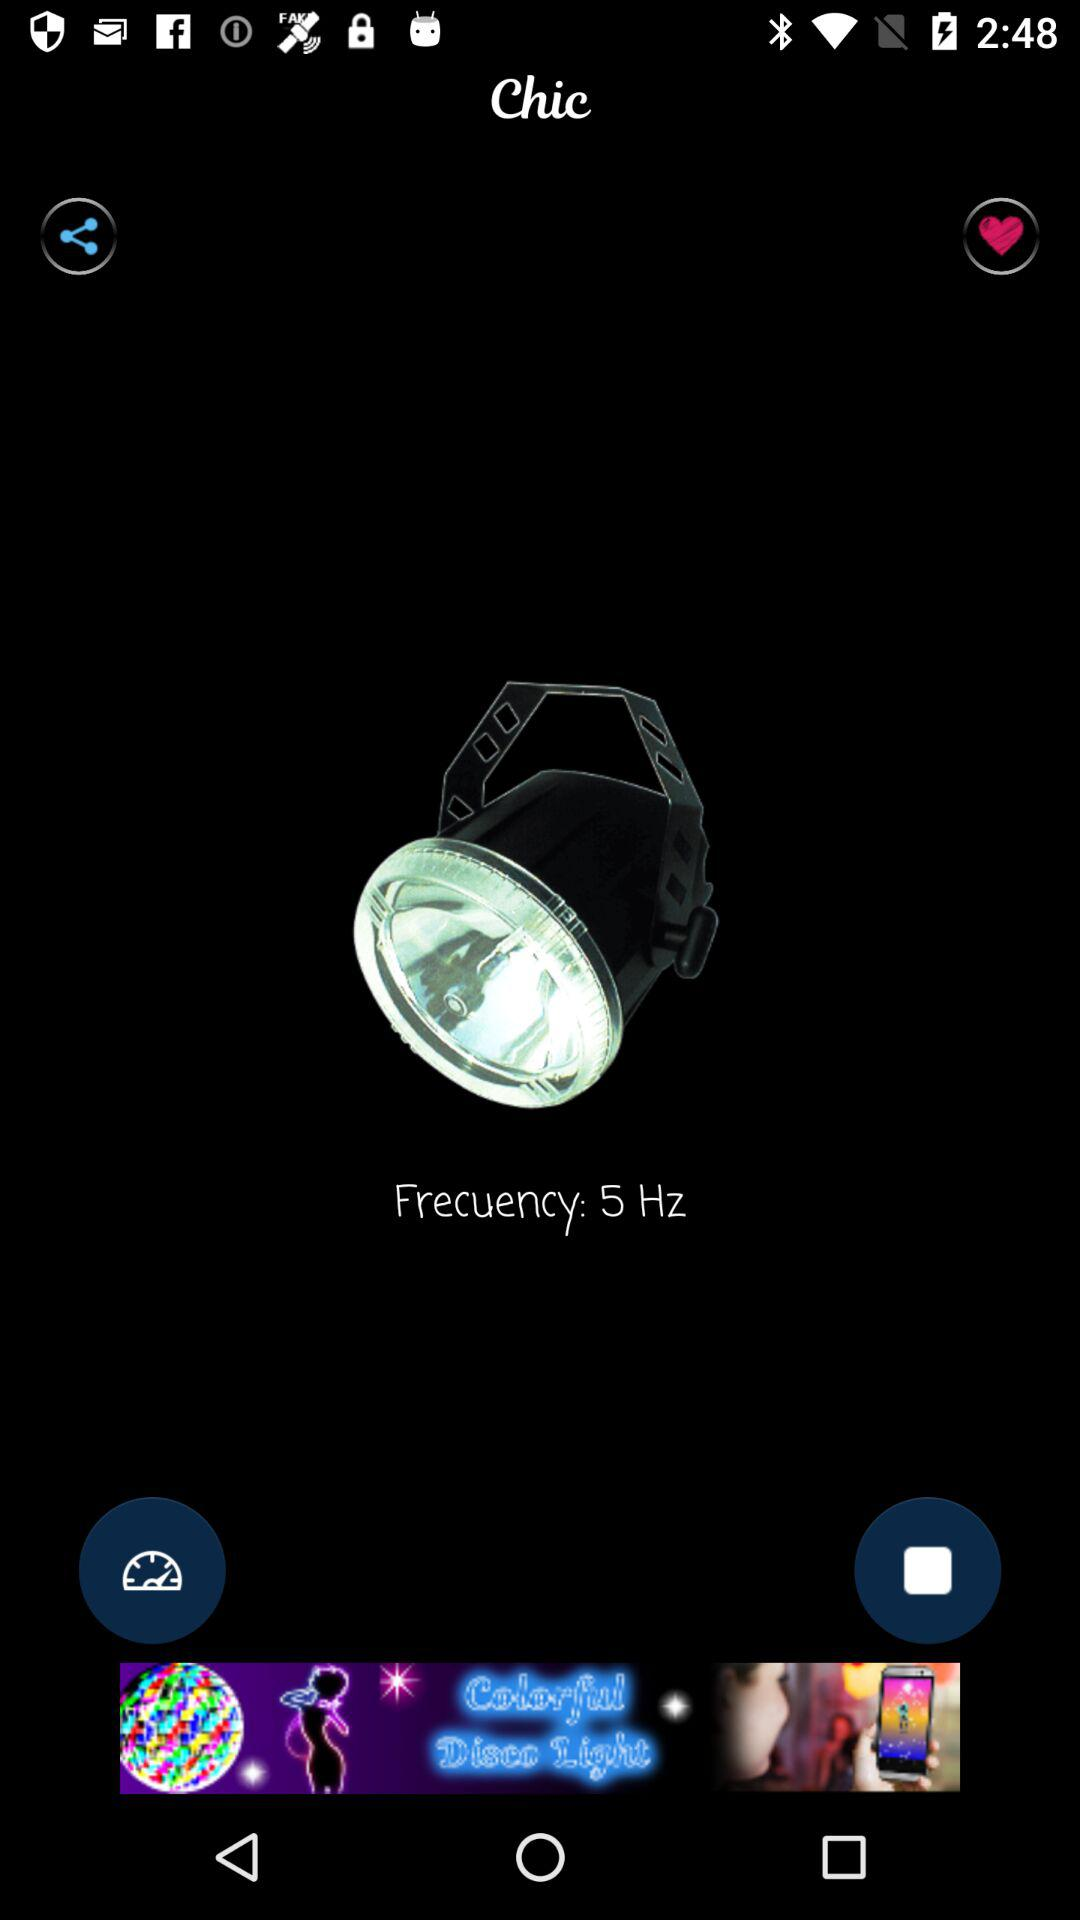What is the mentioned frequency? The mentioned frequency is 5 Hz. 